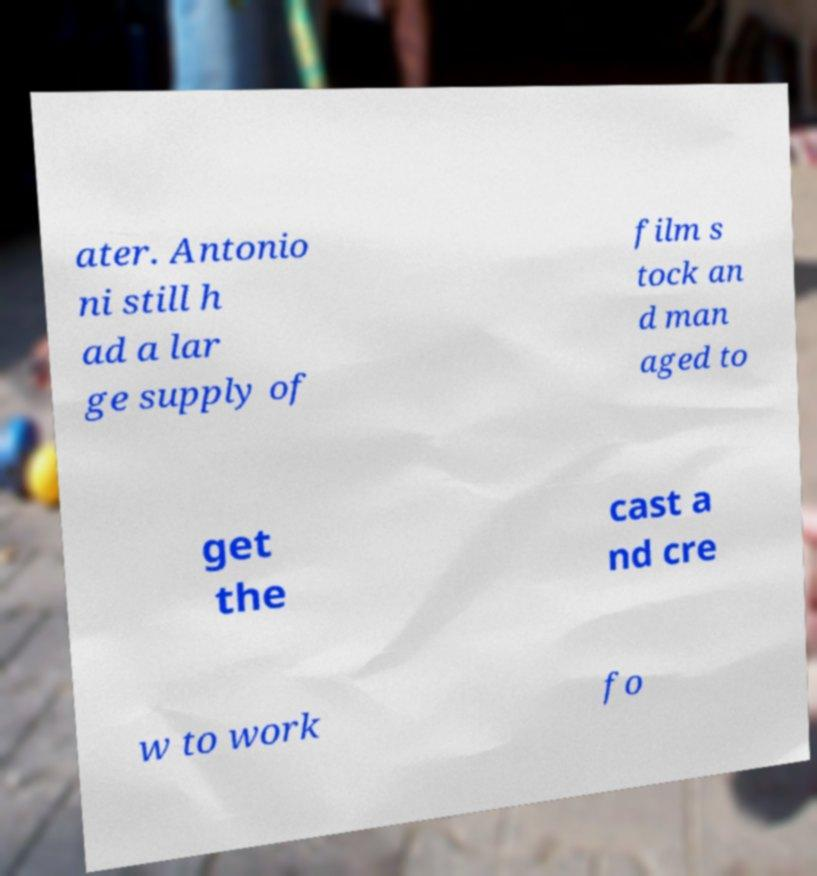Could you assist in decoding the text presented in this image and type it out clearly? ater. Antonio ni still h ad a lar ge supply of film s tock an d man aged to get the cast a nd cre w to work fo 